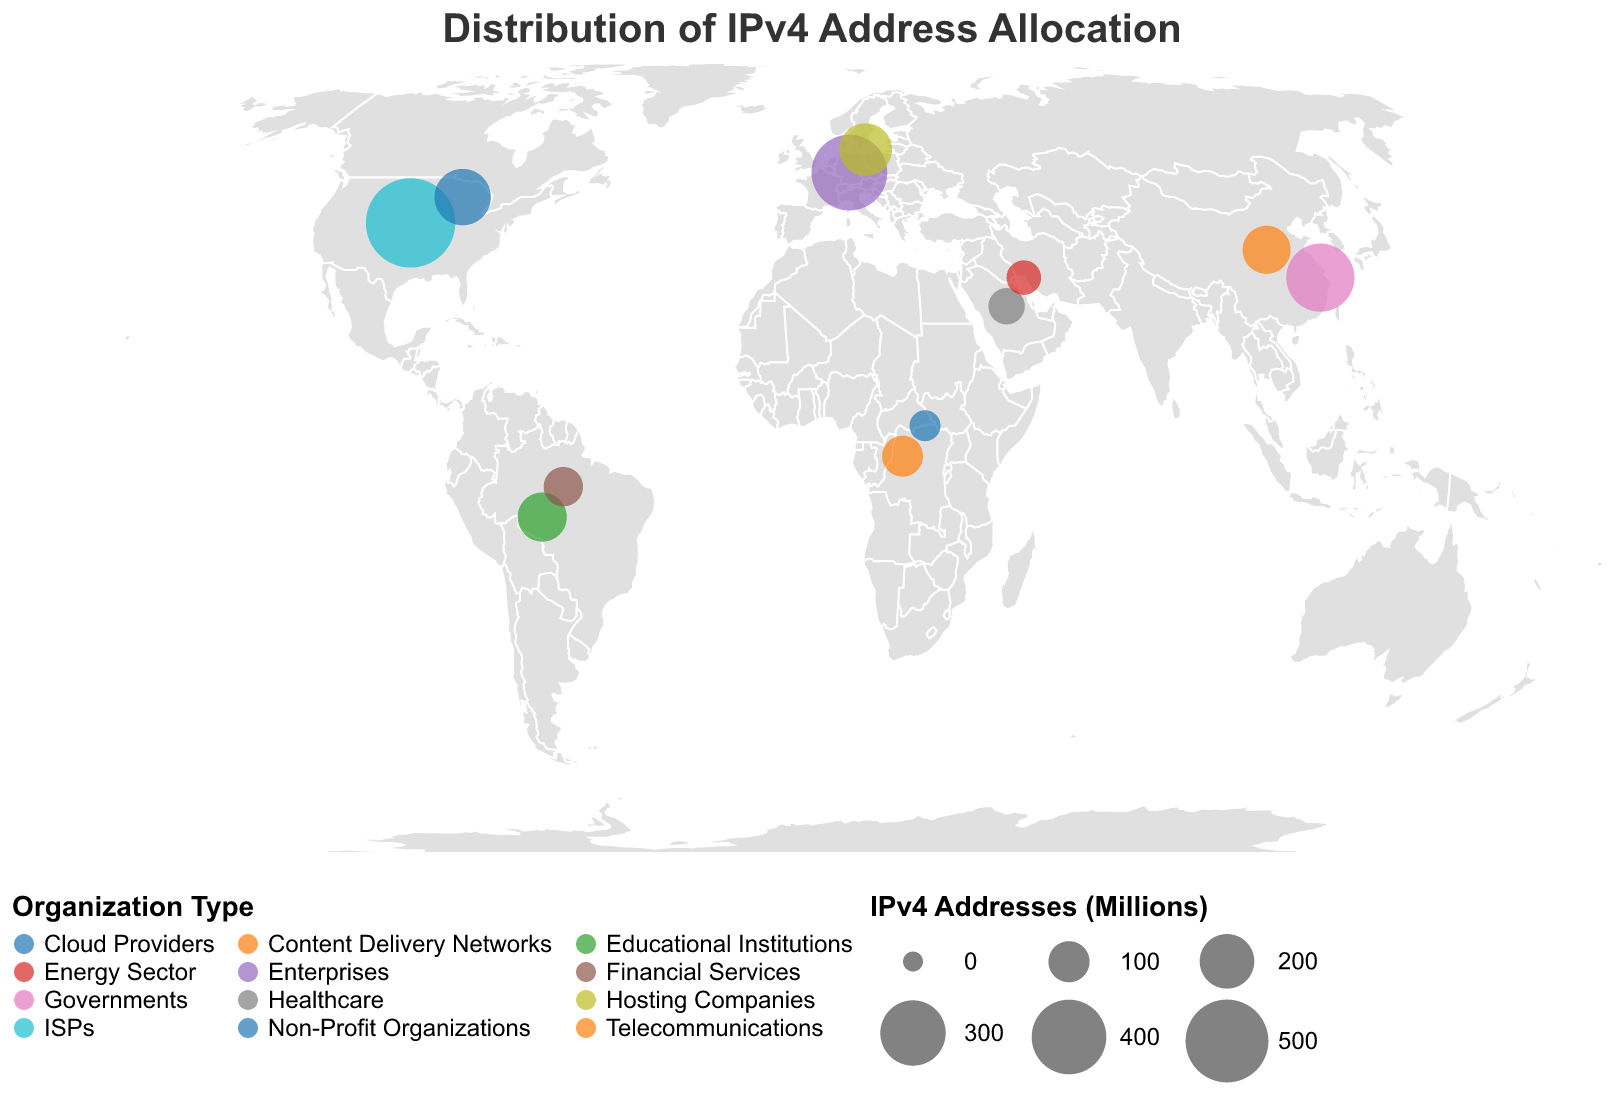What is the total number of IPv4 addresses allocated to organizations in North America? Sum the IPv4 addresses allocated to ISPs and Cloud Providers in North America: 587.3 + 215.4
Answer: 802.7 Which region has the highest number of IPv4 addresses allocated to a single organization type? Look for the largest circle in the figure and verify the underlying numbers. In this case, North America's ISPs have 587.3 million IPv4 addresses, which is the highest.
Answer: North America (ISPs) What is the difference in IPv4 address allocation between ISPs in North America and Enterprises in Europe? Subtract the IPv4 addresses of Enterprises in Europe from the IPv4 addresses of ISPs in North America: 587.3 - 412.6
Answer: 174.7 Which geographical region has the lowest IPv4 address allocation, and what organization type does it pertain to? Identify the smallest circle in the figure and check the corresponding label. The smallest allocation is 43.6 million IPv4 addresses in Africa for Non-Profit Organizations.
Answer: Africa (Non-Profit Organizations) Which organization type in the Asia-Pacific region has the highest number of allocated IPv4 addresses? Compare the two data points for Asia-Pacific (Governments and Content Delivery Networks) and select the one with the higher number of IPv4 addresses. Governments have 328.9 million.
Answer: Governments How many IPv4 addresses are allocated to the Telecommunications sector in Africa? Directly refer to the data point for Telecommunications in Africa. The number provided is 98.5 million.
Answer: 98.5 What is the combined total of IPv4 addresses allocated to Healthcare in the Middle East and Energy Sector in the Middle East? Add the IPv4 addresses for Healthcare and Energy Sector in the Middle East: 72.1 + 61.9
Answer: 134 Compare the IPv4 address allocations between Cloud Providers in North America and Content Delivery Networks in the Asia-Pacific region. Which has more and by how much? Cloud Providers in North America have 215.4 million IPv4 addresses, and Content Delivery Networks in Asia-Pacific have 147.8 million. The difference is 215.4 - 147.8.
Answer: Cloud Providers in North America by 67.6 How many organization types are displayed in the figure? Count the distinct organization types listed in the data values.
Answer: 12 Which region has the highest diversity of organization types allocated with IPv4 addresses, and how many types are there? Look for the region listed the most number of times with different organization types; North America appears twice (ISPs, Cloud Providers).
Answer: North America (2 types) 